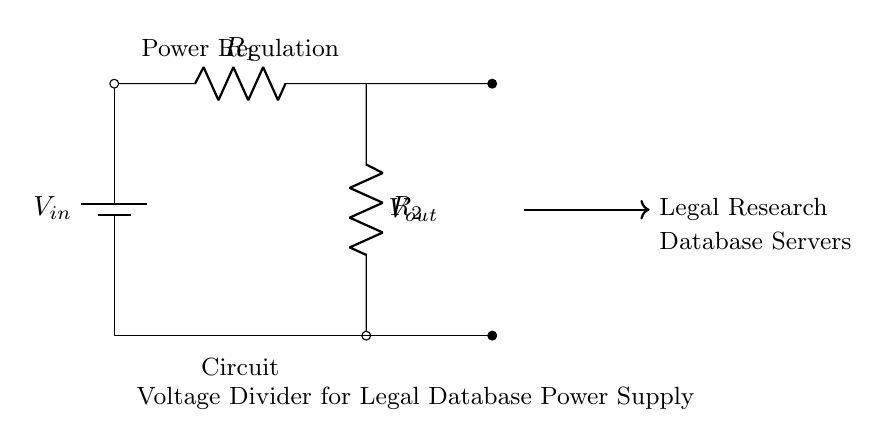What is the input voltage of the circuit? The input voltage, labeled as V_in, is the voltage supplied by the battery. The diagram indicates it is connected at the top of the circuit.
Answer: V_in What are the components in the circuit? The components visible in the circuit diagram are a battery, two resistors, and connecting wires. The resistors are labeled R_1 and R_2.
Answer: Battery, R_1, R_2 What does the output voltage depend on? The output voltage, V_out, is determined by the ratio of the resistances R_1 and R_2, as well as the input voltage V_in according to the voltage divider rule.
Answer: It depends on R_1, R_2, and V_in What is the purpose of the voltage divider in this context? The voltage divider regulates the power supply to ensure a stable voltage for the legal research database servers' operation. This is important for their efficient functioning and protection from voltage spikes.
Answer: Power regulation How does the voltage divider affect V_out? The voltage divider affects V_out by dividing the input voltage based on the resistive values of R_1 and R_2, leading to a lower voltage suitable for the servers. This is calculated using the formula V_out = V_in * (R_2 / (R_1 + R_2)).
Answer: It reduces the voltage What is the function of R_1 and R_2 in the circuit? R_1 and R_2 are used to create the voltage divider effect, where R_1 drops some voltage while allowing V_out to be the voltage across R_2. Their values dictate the final output voltage available for the database servers.
Answer: Create voltage division 